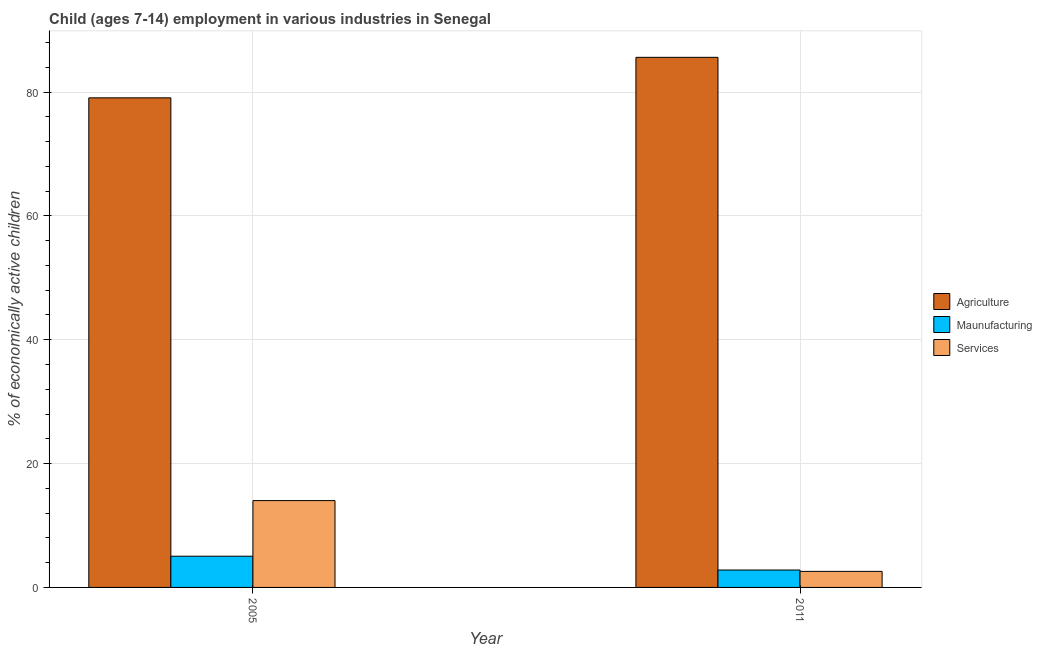How many groups of bars are there?
Your response must be concise. 2. Are the number of bars on each tick of the X-axis equal?
Provide a short and direct response. Yes. How many bars are there on the 2nd tick from the left?
Provide a succinct answer. 3. How many bars are there on the 2nd tick from the right?
Ensure brevity in your answer.  3. What is the label of the 2nd group of bars from the left?
Provide a short and direct response. 2011. What is the percentage of economically active children in manufacturing in 2005?
Keep it short and to the point. 5.04. Across all years, what is the maximum percentage of economically active children in services?
Offer a terse response. 14.02. Across all years, what is the minimum percentage of economically active children in manufacturing?
Make the answer very short. 2.81. In which year was the percentage of economically active children in manufacturing maximum?
Your answer should be very brief. 2005. What is the total percentage of economically active children in manufacturing in the graph?
Keep it short and to the point. 7.85. What is the difference between the percentage of economically active children in services in 2005 and that in 2011?
Give a very brief answer. 11.43. What is the difference between the percentage of economically active children in services in 2011 and the percentage of economically active children in manufacturing in 2005?
Your response must be concise. -11.43. What is the average percentage of economically active children in agriculture per year?
Keep it short and to the point. 82.33. In how many years, is the percentage of economically active children in agriculture greater than 12 %?
Offer a terse response. 2. What is the ratio of the percentage of economically active children in manufacturing in 2005 to that in 2011?
Your answer should be compact. 1.79. In how many years, is the percentage of economically active children in agriculture greater than the average percentage of economically active children in agriculture taken over all years?
Your response must be concise. 1. What does the 1st bar from the left in 2005 represents?
Your answer should be very brief. Agriculture. What does the 3rd bar from the right in 2011 represents?
Provide a succinct answer. Agriculture. Is it the case that in every year, the sum of the percentage of economically active children in agriculture and percentage of economically active children in manufacturing is greater than the percentage of economically active children in services?
Provide a succinct answer. Yes. How many bars are there?
Keep it short and to the point. 6. How many years are there in the graph?
Keep it short and to the point. 2. Does the graph contain grids?
Your answer should be very brief. Yes. Where does the legend appear in the graph?
Provide a succinct answer. Center right. How many legend labels are there?
Offer a terse response. 3. How are the legend labels stacked?
Provide a succinct answer. Vertical. What is the title of the graph?
Give a very brief answer. Child (ages 7-14) employment in various industries in Senegal. Does "Natural Gas" appear as one of the legend labels in the graph?
Ensure brevity in your answer.  No. What is the label or title of the Y-axis?
Ensure brevity in your answer.  % of economically active children. What is the % of economically active children in Agriculture in 2005?
Provide a short and direct response. 79.06. What is the % of economically active children of Maunufacturing in 2005?
Your response must be concise. 5.04. What is the % of economically active children of Services in 2005?
Your answer should be compact. 14.02. What is the % of economically active children in Agriculture in 2011?
Provide a succinct answer. 85.6. What is the % of economically active children of Maunufacturing in 2011?
Keep it short and to the point. 2.81. What is the % of economically active children of Services in 2011?
Keep it short and to the point. 2.59. Across all years, what is the maximum % of economically active children in Agriculture?
Offer a very short reply. 85.6. Across all years, what is the maximum % of economically active children of Maunufacturing?
Your answer should be very brief. 5.04. Across all years, what is the maximum % of economically active children in Services?
Make the answer very short. 14.02. Across all years, what is the minimum % of economically active children in Agriculture?
Give a very brief answer. 79.06. Across all years, what is the minimum % of economically active children in Maunufacturing?
Provide a short and direct response. 2.81. Across all years, what is the minimum % of economically active children in Services?
Your answer should be compact. 2.59. What is the total % of economically active children in Agriculture in the graph?
Provide a short and direct response. 164.66. What is the total % of economically active children of Maunufacturing in the graph?
Offer a very short reply. 7.85. What is the total % of economically active children in Services in the graph?
Keep it short and to the point. 16.61. What is the difference between the % of economically active children in Agriculture in 2005 and that in 2011?
Your response must be concise. -6.54. What is the difference between the % of economically active children of Maunufacturing in 2005 and that in 2011?
Your answer should be compact. 2.23. What is the difference between the % of economically active children of Services in 2005 and that in 2011?
Keep it short and to the point. 11.43. What is the difference between the % of economically active children in Agriculture in 2005 and the % of economically active children in Maunufacturing in 2011?
Your answer should be compact. 76.25. What is the difference between the % of economically active children of Agriculture in 2005 and the % of economically active children of Services in 2011?
Your response must be concise. 76.47. What is the difference between the % of economically active children of Maunufacturing in 2005 and the % of economically active children of Services in 2011?
Provide a short and direct response. 2.45. What is the average % of economically active children of Agriculture per year?
Your answer should be very brief. 82.33. What is the average % of economically active children in Maunufacturing per year?
Provide a succinct answer. 3.92. What is the average % of economically active children of Services per year?
Keep it short and to the point. 8.3. In the year 2005, what is the difference between the % of economically active children of Agriculture and % of economically active children of Maunufacturing?
Ensure brevity in your answer.  74.02. In the year 2005, what is the difference between the % of economically active children of Agriculture and % of economically active children of Services?
Keep it short and to the point. 65.04. In the year 2005, what is the difference between the % of economically active children of Maunufacturing and % of economically active children of Services?
Provide a short and direct response. -8.98. In the year 2011, what is the difference between the % of economically active children in Agriculture and % of economically active children in Maunufacturing?
Give a very brief answer. 82.79. In the year 2011, what is the difference between the % of economically active children of Agriculture and % of economically active children of Services?
Offer a very short reply. 83.01. In the year 2011, what is the difference between the % of economically active children of Maunufacturing and % of economically active children of Services?
Offer a very short reply. 0.22. What is the ratio of the % of economically active children of Agriculture in 2005 to that in 2011?
Keep it short and to the point. 0.92. What is the ratio of the % of economically active children in Maunufacturing in 2005 to that in 2011?
Make the answer very short. 1.79. What is the ratio of the % of economically active children in Services in 2005 to that in 2011?
Your response must be concise. 5.41. What is the difference between the highest and the second highest % of economically active children in Agriculture?
Give a very brief answer. 6.54. What is the difference between the highest and the second highest % of economically active children of Maunufacturing?
Your answer should be very brief. 2.23. What is the difference between the highest and the second highest % of economically active children of Services?
Keep it short and to the point. 11.43. What is the difference between the highest and the lowest % of economically active children of Agriculture?
Your answer should be compact. 6.54. What is the difference between the highest and the lowest % of economically active children in Maunufacturing?
Ensure brevity in your answer.  2.23. What is the difference between the highest and the lowest % of economically active children in Services?
Offer a terse response. 11.43. 